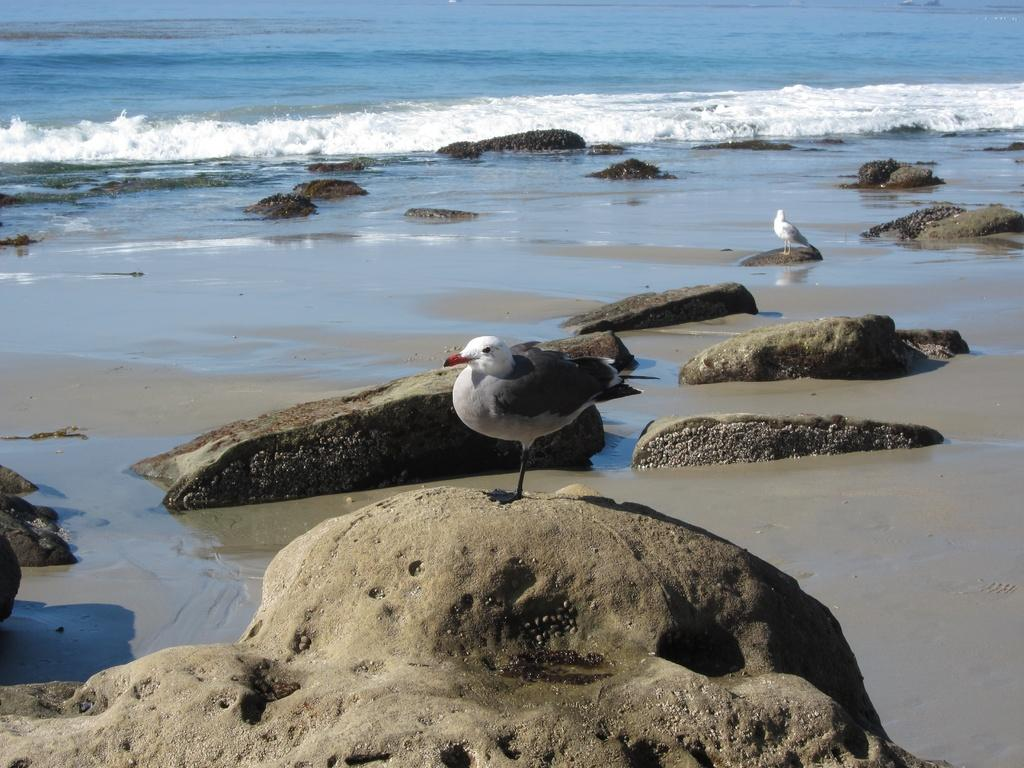How many birds are present in the image? There are two birds in the image. What are the birds standing on? The birds are standing on rocks. What can be seen in the background of the image? There is water visible in the background of the image. What type of doll is being used in the fight between the birds in the image? There is no doll present in the image, and the birds are not engaged in a fight. 